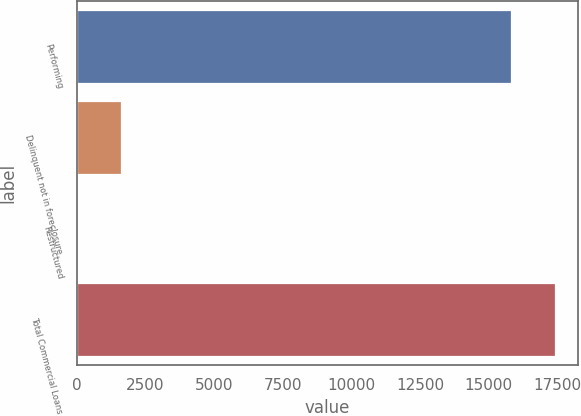Convert chart to OTSL. <chart><loc_0><loc_0><loc_500><loc_500><bar_chart><fcel>Performing<fcel>Delinquent not in foreclosure<fcel>Restructured<fcel>Total Commercial Loans<nl><fcel>15812<fcel>1596.4<fcel>10<fcel>17398.4<nl></chart> 